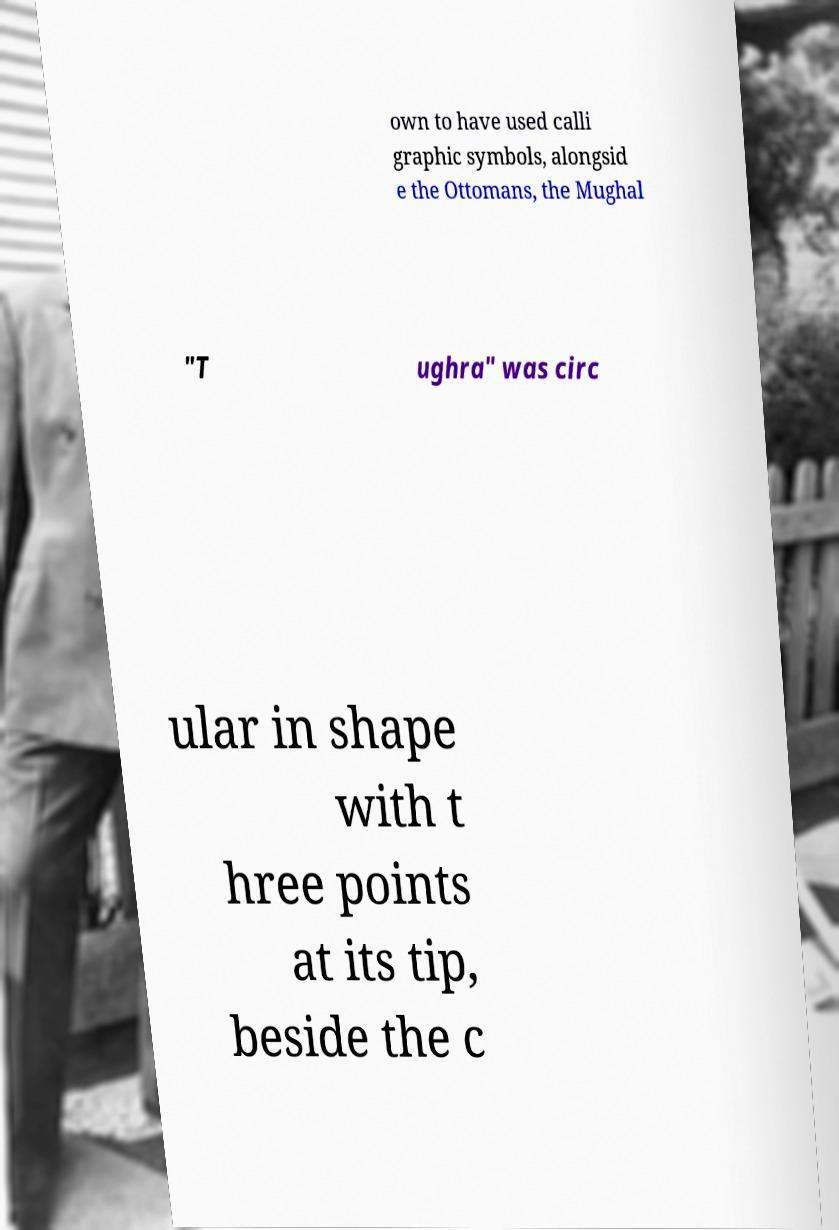Please read and relay the text visible in this image. What does it say? own to have used calli graphic symbols, alongsid e the Ottomans, the Mughal "T ughra" was circ ular in shape with t hree points at its tip, beside the c 